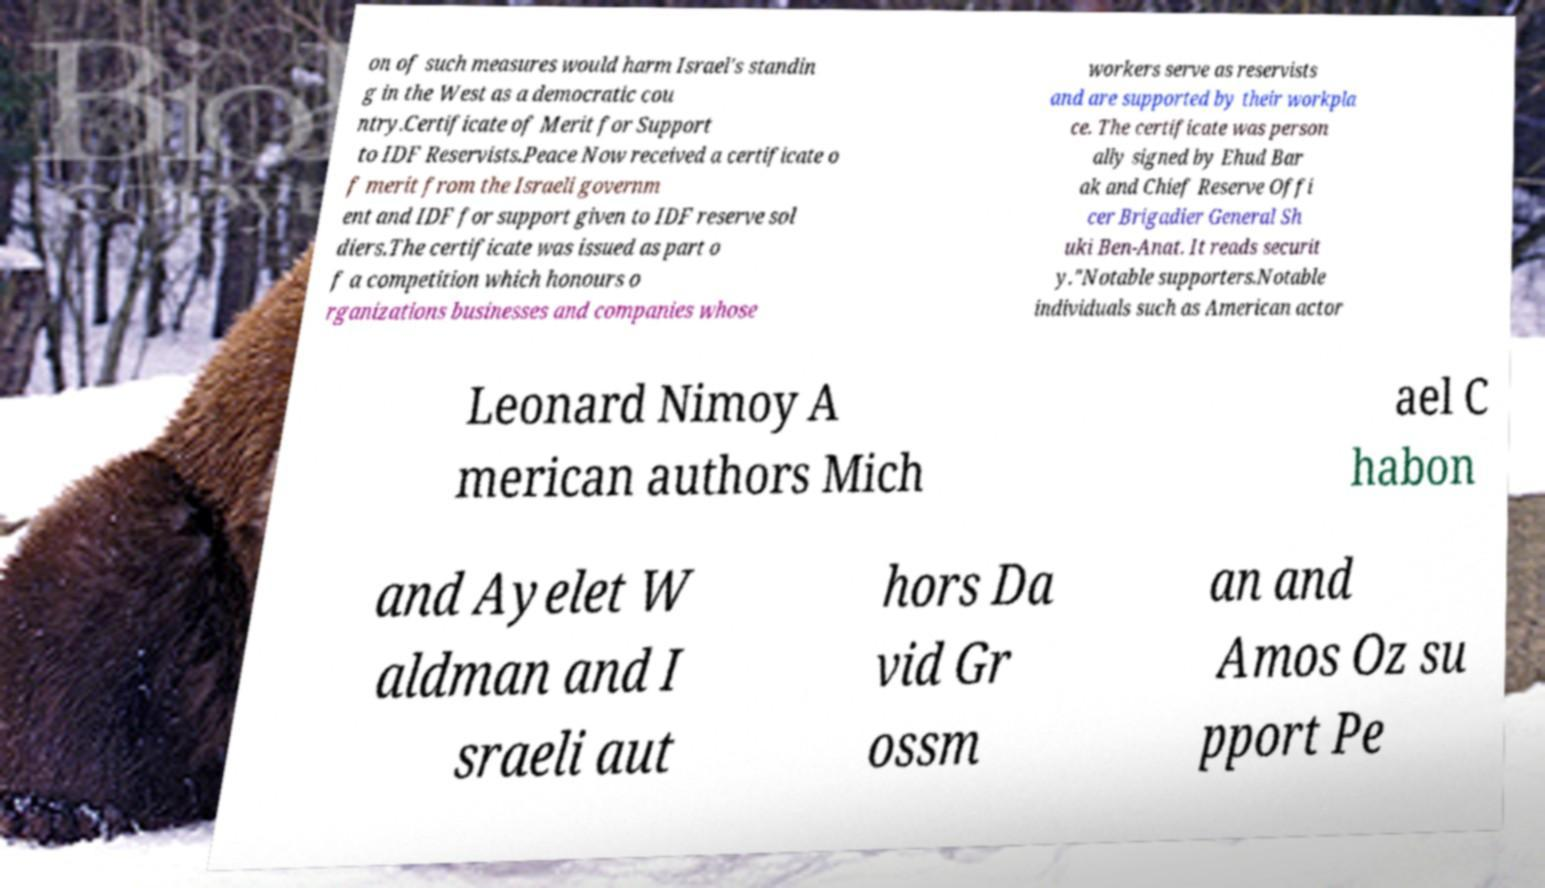There's text embedded in this image that I need extracted. Can you transcribe it verbatim? on of such measures would harm Israel's standin g in the West as a democratic cou ntry.Certificate of Merit for Support to IDF Reservists.Peace Now received a certificate o f merit from the Israeli governm ent and IDF for support given to IDF reserve sol diers.The certificate was issued as part o f a competition which honours o rganizations businesses and companies whose workers serve as reservists and are supported by their workpla ce. The certificate was person ally signed by Ehud Bar ak and Chief Reserve Offi cer Brigadier General Sh uki Ben-Anat. It reads securit y."Notable supporters.Notable individuals such as American actor Leonard Nimoy A merican authors Mich ael C habon and Ayelet W aldman and I sraeli aut hors Da vid Gr ossm an and Amos Oz su pport Pe 